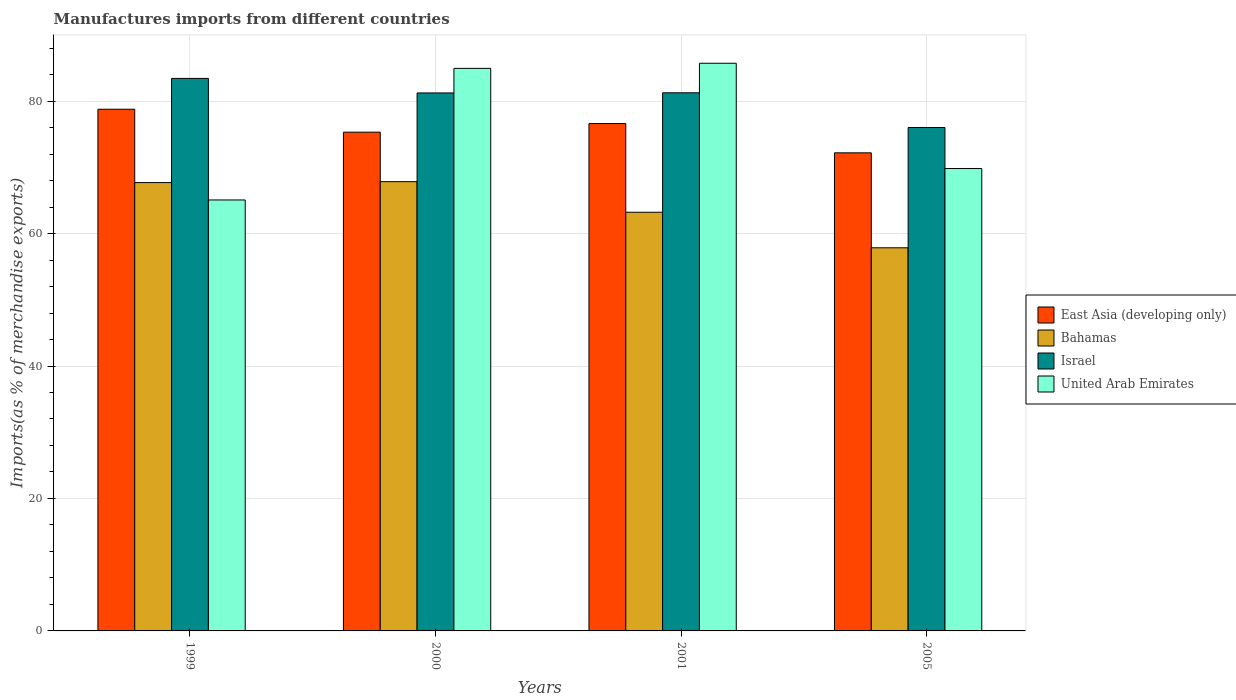How many different coloured bars are there?
Provide a succinct answer. 4. Are the number of bars per tick equal to the number of legend labels?
Give a very brief answer. Yes. How many bars are there on the 1st tick from the left?
Keep it short and to the point. 4. What is the percentage of imports to different countries in East Asia (developing only) in 2005?
Ensure brevity in your answer.  72.19. Across all years, what is the maximum percentage of imports to different countries in Bahamas?
Your answer should be compact. 67.84. Across all years, what is the minimum percentage of imports to different countries in Bahamas?
Your answer should be compact. 57.85. In which year was the percentage of imports to different countries in Israel minimum?
Offer a terse response. 2005. What is the total percentage of imports to different countries in East Asia (developing only) in the graph?
Ensure brevity in your answer.  302.89. What is the difference between the percentage of imports to different countries in East Asia (developing only) in 1999 and that in 2005?
Give a very brief answer. 6.58. What is the difference between the percentage of imports to different countries in East Asia (developing only) in 2000 and the percentage of imports to different countries in United Arab Emirates in 2001?
Provide a short and direct response. -10.4. What is the average percentage of imports to different countries in Israel per year?
Your answer should be very brief. 80.48. In the year 1999, what is the difference between the percentage of imports to different countries in Bahamas and percentage of imports to different countries in Israel?
Provide a succinct answer. -15.73. In how many years, is the percentage of imports to different countries in Israel greater than 44 %?
Provide a short and direct response. 4. What is the ratio of the percentage of imports to different countries in United Arab Emirates in 1999 to that in 2000?
Keep it short and to the point. 0.77. Is the difference between the percentage of imports to different countries in Bahamas in 2001 and 2005 greater than the difference between the percentage of imports to different countries in Israel in 2001 and 2005?
Keep it short and to the point. Yes. What is the difference between the highest and the second highest percentage of imports to different countries in East Asia (developing only)?
Provide a short and direct response. 2.16. What is the difference between the highest and the lowest percentage of imports to different countries in East Asia (developing only)?
Give a very brief answer. 6.58. In how many years, is the percentage of imports to different countries in Israel greater than the average percentage of imports to different countries in Israel taken over all years?
Ensure brevity in your answer.  3. Is the sum of the percentage of imports to different countries in United Arab Emirates in 2000 and 2005 greater than the maximum percentage of imports to different countries in Israel across all years?
Give a very brief answer. Yes. What does the 2nd bar from the left in 1999 represents?
Give a very brief answer. Bahamas. Is it the case that in every year, the sum of the percentage of imports to different countries in East Asia (developing only) and percentage of imports to different countries in Israel is greater than the percentage of imports to different countries in United Arab Emirates?
Make the answer very short. Yes. Are all the bars in the graph horizontal?
Offer a very short reply. No. How many years are there in the graph?
Your answer should be compact. 4. What is the difference between two consecutive major ticks on the Y-axis?
Your answer should be compact. 20. Does the graph contain any zero values?
Ensure brevity in your answer.  No. Does the graph contain grids?
Your answer should be compact. Yes. Where does the legend appear in the graph?
Provide a succinct answer. Center right. How many legend labels are there?
Give a very brief answer. 4. What is the title of the graph?
Provide a short and direct response. Manufactures imports from different countries. What is the label or title of the Y-axis?
Your answer should be very brief. Imports(as % of merchandise exports). What is the Imports(as % of merchandise exports) in East Asia (developing only) in 1999?
Provide a succinct answer. 78.77. What is the Imports(as % of merchandise exports) of Bahamas in 1999?
Provide a succinct answer. 67.7. What is the Imports(as % of merchandise exports) in Israel in 1999?
Give a very brief answer. 83.43. What is the Imports(as % of merchandise exports) of United Arab Emirates in 1999?
Your answer should be very brief. 65.07. What is the Imports(as % of merchandise exports) of East Asia (developing only) in 2000?
Your response must be concise. 75.31. What is the Imports(as % of merchandise exports) of Bahamas in 2000?
Provide a short and direct response. 67.84. What is the Imports(as % of merchandise exports) in Israel in 2000?
Ensure brevity in your answer.  81.23. What is the Imports(as % of merchandise exports) in United Arab Emirates in 2000?
Make the answer very short. 84.94. What is the Imports(as % of merchandise exports) in East Asia (developing only) in 2001?
Offer a very short reply. 76.61. What is the Imports(as % of merchandise exports) in Bahamas in 2001?
Offer a very short reply. 63.22. What is the Imports(as % of merchandise exports) in Israel in 2001?
Provide a succinct answer. 81.25. What is the Imports(as % of merchandise exports) of United Arab Emirates in 2001?
Offer a terse response. 85.72. What is the Imports(as % of merchandise exports) of East Asia (developing only) in 2005?
Offer a very short reply. 72.19. What is the Imports(as % of merchandise exports) of Bahamas in 2005?
Offer a terse response. 57.85. What is the Imports(as % of merchandise exports) in Israel in 2005?
Your answer should be very brief. 76.02. What is the Imports(as % of merchandise exports) in United Arab Emirates in 2005?
Ensure brevity in your answer.  69.82. Across all years, what is the maximum Imports(as % of merchandise exports) in East Asia (developing only)?
Provide a short and direct response. 78.77. Across all years, what is the maximum Imports(as % of merchandise exports) of Bahamas?
Provide a succinct answer. 67.84. Across all years, what is the maximum Imports(as % of merchandise exports) of Israel?
Your answer should be compact. 83.43. Across all years, what is the maximum Imports(as % of merchandise exports) in United Arab Emirates?
Your answer should be compact. 85.72. Across all years, what is the minimum Imports(as % of merchandise exports) of East Asia (developing only)?
Give a very brief answer. 72.19. Across all years, what is the minimum Imports(as % of merchandise exports) of Bahamas?
Offer a very short reply. 57.85. Across all years, what is the minimum Imports(as % of merchandise exports) of Israel?
Keep it short and to the point. 76.02. Across all years, what is the minimum Imports(as % of merchandise exports) of United Arab Emirates?
Your answer should be compact. 65.07. What is the total Imports(as % of merchandise exports) of East Asia (developing only) in the graph?
Ensure brevity in your answer.  302.89. What is the total Imports(as % of merchandise exports) in Bahamas in the graph?
Make the answer very short. 256.6. What is the total Imports(as % of merchandise exports) of Israel in the graph?
Make the answer very short. 321.93. What is the total Imports(as % of merchandise exports) in United Arab Emirates in the graph?
Make the answer very short. 305.55. What is the difference between the Imports(as % of merchandise exports) in East Asia (developing only) in 1999 and that in 2000?
Provide a short and direct response. 3.46. What is the difference between the Imports(as % of merchandise exports) of Bahamas in 1999 and that in 2000?
Give a very brief answer. -0.14. What is the difference between the Imports(as % of merchandise exports) of Israel in 1999 and that in 2000?
Make the answer very short. 2.2. What is the difference between the Imports(as % of merchandise exports) in United Arab Emirates in 1999 and that in 2000?
Give a very brief answer. -19.87. What is the difference between the Imports(as % of merchandise exports) of East Asia (developing only) in 1999 and that in 2001?
Give a very brief answer. 2.16. What is the difference between the Imports(as % of merchandise exports) of Bahamas in 1999 and that in 2001?
Offer a terse response. 4.48. What is the difference between the Imports(as % of merchandise exports) of Israel in 1999 and that in 2001?
Offer a terse response. 2.18. What is the difference between the Imports(as % of merchandise exports) in United Arab Emirates in 1999 and that in 2001?
Provide a succinct answer. -20.64. What is the difference between the Imports(as % of merchandise exports) of East Asia (developing only) in 1999 and that in 2005?
Provide a succinct answer. 6.58. What is the difference between the Imports(as % of merchandise exports) in Bahamas in 1999 and that in 2005?
Give a very brief answer. 9.85. What is the difference between the Imports(as % of merchandise exports) in Israel in 1999 and that in 2005?
Provide a short and direct response. 7.41. What is the difference between the Imports(as % of merchandise exports) of United Arab Emirates in 1999 and that in 2005?
Ensure brevity in your answer.  -4.75. What is the difference between the Imports(as % of merchandise exports) of East Asia (developing only) in 2000 and that in 2001?
Offer a terse response. -1.3. What is the difference between the Imports(as % of merchandise exports) in Bahamas in 2000 and that in 2001?
Your response must be concise. 4.62. What is the difference between the Imports(as % of merchandise exports) of Israel in 2000 and that in 2001?
Provide a succinct answer. -0.02. What is the difference between the Imports(as % of merchandise exports) of United Arab Emirates in 2000 and that in 2001?
Ensure brevity in your answer.  -0.77. What is the difference between the Imports(as % of merchandise exports) in East Asia (developing only) in 2000 and that in 2005?
Give a very brief answer. 3.12. What is the difference between the Imports(as % of merchandise exports) in Bahamas in 2000 and that in 2005?
Make the answer very short. 9.99. What is the difference between the Imports(as % of merchandise exports) in Israel in 2000 and that in 2005?
Provide a short and direct response. 5.22. What is the difference between the Imports(as % of merchandise exports) of United Arab Emirates in 2000 and that in 2005?
Offer a very short reply. 15.13. What is the difference between the Imports(as % of merchandise exports) in East Asia (developing only) in 2001 and that in 2005?
Your answer should be compact. 4.42. What is the difference between the Imports(as % of merchandise exports) in Bahamas in 2001 and that in 2005?
Make the answer very short. 5.37. What is the difference between the Imports(as % of merchandise exports) in Israel in 2001 and that in 2005?
Your answer should be very brief. 5.24. What is the difference between the Imports(as % of merchandise exports) of United Arab Emirates in 2001 and that in 2005?
Offer a terse response. 15.9. What is the difference between the Imports(as % of merchandise exports) in East Asia (developing only) in 1999 and the Imports(as % of merchandise exports) in Bahamas in 2000?
Provide a short and direct response. 10.94. What is the difference between the Imports(as % of merchandise exports) of East Asia (developing only) in 1999 and the Imports(as % of merchandise exports) of Israel in 2000?
Your answer should be very brief. -2.46. What is the difference between the Imports(as % of merchandise exports) of East Asia (developing only) in 1999 and the Imports(as % of merchandise exports) of United Arab Emirates in 2000?
Provide a short and direct response. -6.17. What is the difference between the Imports(as % of merchandise exports) of Bahamas in 1999 and the Imports(as % of merchandise exports) of Israel in 2000?
Keep it short and to the point. -13.54. What is the difference between the Imports(as % of merchandise exports) of Bahamas in 1999 and the Imports(as % of merchandise exports) of United Arab Emirates in 2000?
Offer a terse response. -17.25. What is the difference between the Imports(as % of merchandise exports) of Israel in 1999 and the Imports(as % of merchandise exports) of United Arab Emirates in 2000?
Ensure brevity in your answer.  -1.51. What is the difference between the Imports(as % of merchandise exports) in East Asia (developing only) in 1999 and the Imports(as % of merchandise exports) in Bahamas in 2001?
Make the answer very short. 15.55. What is the difference between the Imports(as % of merchandise exports) in East Asia (developing only) in 1999 and the Imports(as % of merchandise exports) in Israel in 2001?
Make the answer very short. -2.48. What is the difference between the Imports(as % of merchandise exports) in East Asia (developing only) in 1999 and the Imports(as % of merchandise exports) in United Arab Emirates in 2001?
Provide a short and direct response. -6.94. What is the difference between the Imports(as % of merchandise exports) in Bahamas in 1999 and the Imports(as % of merchandise exports) in Israel in 2001?
Make the answer very short. -13.56. What is the difference between the Imports(as % of merchandise exports) in Bahamas in 1999 and the Imports(as % of merchandise exports) in United Arab Emirates in 2001?
Offer a very short reply. -18.02. What is the difference between the Imports(as % of merchandise exports) of Israel in 1999 and the Imports(as % of merchandise exports) of United Arab Emirates in 2001?
Keep it short and to the point. -2.29. What is the difference between the Imports(as % of merchandise exports) of East Asia (developing only) in 1999 and the Imports(as % of merchandise exports) of Bahamas in 2005?
Your answer should be compact. 20.92. What is the difference between the Imports(as % of merchandise exports) in East Asia (developing only) in 1999 and the Imports(as % of merchandise exports) in Israel in 2005?
Provide a succinct answer. 2.76. What is the difference between the Imports(as % of merchandise exports) in East Asia (developing only) in 1999 and the Imports(as % of merchandise exports) in United Arab Emirates in 2005?
Provide a succinct answer. 8.95. What is the difference between the Imports(as % of merchandise exports) of Bahamas in 1999 and the Imports(as % of merchandise exports) of Israel in 2005?
Your response must be concise. -8.32. What is the difference between the Imports(as % of merchandise exports) in Bahamas in 1999 and the Imports(as % of merchandise exports) in United Arab Emirates in 2005?
Provide a succinct answer. -2.12. What is the difference between the Imports(as % of merchandise exports) of Israel in 1999 and the Imports(as % of merchandise exports) of United Arab Emirates in 2005?
Ensure brevity in your answer.  13.61. What is the difference between the Imports(as % of merchandise exports) of East Asia (developing only) in 2000 and the Imports(as % of merchandise exports) of Bahamas in 2001?
Your answer should be compact. 12.09. What is the difference between the Imports(as % of merchandise exports) of East Asia (developing only) in 2000 and the Imports(as % of merchandise exports) of Israel in 2001?
Your answer should be very brief. -5.94. What is the difference between the Imports(as % of merchandise exports) of East Asia (developing only) in 2000 and the Imports(as % of merchandise exports) of United Arab Emirates in 2001?
Your answer should be compact. -10.4. What is the difference between the Imports(as % of merchandise exports) of Bahamas in 2000 and the Imports(as % of merchandise exports) of Israel in 2001?
Offer a very short reply. -13.42. What is the difference between the Imports(as % of merchandise exports) in Bahamas in 2000 and the Imports(as % of merchandise exports) in United Arab Emirates in 2001?
Provide a short and direct response. -17.88. What is the difference between the Imports(as % of merchandise exports) in Israel in 2000 and the Imports(as % of merchandise exports) in United Arab Emirates in 2001?
Ensure brevity in your answer.  -4.48. What is the difference between the Imports(as % of merchandise exports) in East Asia (developing only) in 2000 and the Imports(as % of merchandise exports) in Bahamas in 2005?
Your answer should be compact. 17.46. What is the difference between the Imports(as % of merchandise exports) of East Asia (developing only) in 2000 and the Imports(as % of merchandise exports) of Israel in 2005?
Make the answer very short. -0.7. What is the difference between the Imports(as % of merchandise exports) in East Asia (developing only) in 2000 and the Imports(as % of merchandise exports) in United Arab Emirates in 2005?
Make the answer very short. 5.49. What is the difference between the Imports(as % of merchandise exports) of Bahamas in 2000 and the Imports(as % of merchandise exports) of Israel in 2005?
Make the answer very short. -8.18. What is the difference between the Imports(as % of merchandise exports) of Bahamas in 2000 and the Imports(as % of merchandise exports) of United Arab Emirates in 2005?
Offer a very short reply. -1.98. What is the difference between the Imports(as % of merchandise exports) in Israel in 2000 and the Imports(as % of merchandise exports) in United Arab Emirates in 2005?
Offer a very short reply. 11.41. What is the difference between the Imports(as % of merchandise exports) of East Asia (developing only) in 2001 and the Imports(as % of merchandise exports) of Bahamas in 2005?
Your answer should be compact. 18.76. What is the difference between the Imports(as % of merchandise exports) of East Asia (developing only) in 2001 and the Imports(as % of merchandise exports) of Israel in 2005?
Your answer should be very brief. 0.6. What is the difference between the Imports(as % of merchandise exports) of East Asia (developing only) in 2001 and the Imports(as % of merchandise exports) of United Arab Emirates in 2005?
Your response must be concise. 6.79. What is the difference between the Imports(as % of merchandise exports) of Bahamas in 2001 and the Imports(as % of merchandise exports) of Israel in 2005?
Offer a very short reply. -12.8. What is the difference between the Imports(as % of merchandise exports) in Bahamas in 2001 and the Imports(as % of merchandise exports) in United Arab Emirates in 2005?
Provide a short and direct response. -6.6. What is the difference between the Imports(as % of merchandise exports) of Israel in 2001 and the Imports(as % of merchandise exports) of United Arab Emirates in 2005?
Offer a terse response. 11.43. What is the average Imports(as % of merchandise exports) in East Asia (developing only) per year?
Give a very brief answer. 75.72. What is the average Imports(as % of merchandise exports) of Bahamas per year?
Make the answer very short. 64.15. What is the average Imports(as % of merchandise exports) of Israel per year?
Ensure brevity in your answer.  80.48. What is the average Imports(as % of merchandise exports) of United Arab Emirates per year?
Your answer should be compact. 76.39. In the year 1999, what is the difference between the Imports(as % of merchandise exports) of East Asia (developing only) and Imports(as % of merchandise exports) of Bahamas?
Provide a short and direct response. 11.08. In the year 1999, what is the difference between the Imports(as % of merchandise exports) in East Asia (developing only) and Imports(as % of merchandise exports) in Israel?
Provide a short and direct response. -4.66. In the year 1999, what is the difference between the Imports(as % of merchandise exports) of East Asia (developing only) and Imports(as % of merchandise exports) of United Arab Emirates?
Offer a very short reply. 13.7. In the year 1999, what is the difference between the Imports(as % of merchandise exports) in Bahamas and Imports(as % of merchandise exports) in Israel?
Offer a terse response. -15.73. In the year 1999, what is the difference between the Imports(as % of merchandise exports) of Bahamas and Imports(as % of merchandise exports) of United Arab Emirates?
Your response must be concise. 2.62. In the year 1999, what is the difference between the Imports(as % of merchandise exports) of Israel and Imports(as % of merchandise exports) of United Arab Emirates?
Offer a terse response. 18.36. In the year 2000, what is the difference between the Imports(as % of merchandise exports) of East Asia (developing only) and Imports(as % of merchandise exports) of Bahamas?
Offer a very short reply. 7.47. In the year 2000, what is the difference between the Imports(as % of merchandise exports) in East Asia (developing only) and Imports(as % of merchandise exports) in Israel?
Provide a succinct answer. -5.92. In the year 2000, what is the difference between the Imports(as % of merchandise exports) in East Asia (developing only) and Imports(as % of merchandise exports) in United Arab Emirates?
Provide a short and direct response. -9.63. In the year 2000, what is the difference between the Imports(as % of merchandise exports) of Bahamas and Imports(as % of merchandise exports) of Israel?
Ensure brevity in your answer.  -13.4. In the year 2000, what is the difference between the Imports(as % of merchandise exports) in Bahamas and Imports(as % of merchandise exports) in United Arab Emirates?
Offer a very short reply. -17.11. In the year 2000, what is the difference between the Imports(as % of merchandise exports) of Israel and Imports(as % of merchandise exports) of United Arab Emirates?
Make the answer very short. -3.71. In the year 2001, what is the difference between the Imports(as % of merchandise exports) in East Asia (developing only) and Imports(as % of merchandise exports) in Bahamas?
Make the answer very short. 13.39. In the year 2001, what is the difference between the Imports(as % of merchandise exports) in East Asia (developing only) and Imports(as % of merchandise exports) in Israel?
Provide a succinct answer. -4.64. In the year 2001, what is the difference between the Imports(as % of merchandise exports) in East Asia (developing only) and Imports(as % of merchandise exports) in United Arab Emirates?
Your response must be concise. -9.1. In the year 2001, what is the difference between the Imports(as % of merchandise exports) of Bahamas and Imports(as % of merchandise exports) of Israel?
Make the answer very short. -18.04. In the year 2001, what is the difference between the Imports(as % of merchandise exports) in Bahamas and Imports(as % of merchandise exports) in United Arab Emirates?
Your answer should be very brief. -22.5. In the year 2001, what is the difference between the Imports(as % of merchandise exports) of Israel and Imports(as % of merchandise exports) of United Arab Emirates?
Your answer should be very brief. -4.46. In the year 2005, what is the difference between the Imports(as % of merchandise exports) in East Asia (developing only) and Imports(as % of merchandise exports) in Bahamas?
Offer a very short reply. 14.34. In the year 2005, what is the difference between the Imports(as % of merchandise exports) of East Asia (developing only) and Imports(as % of merchandise exports) of Israel?
Your response must be concise. -3.83. In the year 2005, what is the difference between the Imports(as % of merchandise exports) in East Asia (developing only) and Imports(as % of merchandise exports) in United Arab Emirates?
Offer a terse response. 2.37. In the year 2005, what is the difference between the Imports(as % of merchandise exports) in Bahamas and Imports(as % of merchandise exports) in Israel?
Ensure brevity in your answer.  -18.16. In the year 2005, what is the difference between the Imports(as % of merchandise exports) of Bahamas and Imports(as % of merchandise exports) of United Arab Emirates?
Offer a terse response. -11.97. In the year 2005, what is the difference between the Imports(as % of merchandise exports) in Israel and Imports(as % of merchandise exports) in United Arab Emirates?
Keep it short and to the point. 6.2. What is the ratio of the Imports(as % of merchandise exports) of East Asia (developing only) in 1999 to that in 2000?
Make the answer very short. 1.05. What is the ratio of the Imports(as % of merchandise exports) in United Arab Emirates in 1999 to that in 2000?
Provide a succinct answer. 0.77. What is the ratio of the Imports(as % of merchandise exports) of East Asia (developing only) in 1999 to that in 2001?
Your response must be concise. 1.03. What is the ratio of the Imports(as % of merchandise exports) of Bahamas in 1999 to that in 2001?
Make the answer very short. 1.07. What is the ratio of the Imports(as % of merchandise exports) in Israel in 1999 to that in 2001?
Make the answer very short. 1.03. What is the ratio of the Imports(as % of merchandise exports) of United Arab Emirates in 1999 to that in 2001?
Ensure brevity in your answer.  0.76. What is the ratio of the Imports(as % of merchandise exports) in East Asia (developing only) in 1999 to that in 2005?
Offer a very short reply. 1.09. What is the ratio of the Imports(as % of merchandise exports) of Bahamas in 1999 to that in 2005?
Give a very brief answer. 1.17. What is the ratio of the Imports(as % of merchandise exports) in Israel in 1999 to that in 2005?
Your answer should be very brief. 1.1. What is the ratio of the Imports(as % of merchandise exports) in United Arab Emirates in 1999 to that in 2005?
Ensure brevity in your answer.  0.93. What is the ratio of the Imports(as % of merchandise exports) of Bahamas in 2000 to that in 2001?
Provide a succinct answer. 1.07. What is the ratio of the Imports(as % of merchandise exports) of Israel in 2000 to that in 2001?
Your answer should be compact. 1. What is the ratio of the Imports(as % of merchandise exports) of East Asia (developing only) in 2000 to that in 2005?
Provide a succinct answer. 1.04. What is the ratio of the Imports(as % of merchandise exports) of Bahamas in 2000 to that in 2005?
Keep it short and to the point. 1.17. What is the ratio of the Imports(as % of merchandise exports) in Israel in 2000 to that in 2005?
Give a very brief answer. 1.07. What is the ratio of the Imports(as % of merchandise exports) of United Arab Emirates in 2000 to that in 2005?
Provide a short and direct response. 1.22. What is the ratio of the Imports(as % of merchandise exports) of East Asia (developing only) in 2001 to that in 2005?
Your answer should be very brief. 1.06. What is the ratio of the Imports(as % of merchandise exports) of Bahamas in 2001 to that in 2005?
Provide a short and direct response. 1.09. What is the ratio of the Imports(as % of merchandise exports) in Israel in 2001 to that in 2005?
Provide a succinct answer. 1.07. What is the ratio of the Imports(as % of merchandise exports) in United Arab Emirates in 2001 to that in 2005?
Provide a short and direct response. 1.23. What is the difference between the highest and the second highest Imports(as % of merchandise exports) of East Asia (developing only)?
Your answer should be compact. 2.16. What is the difference between the highest and the second highest Imports(as % of merchandise exports) of Bahamas?
Ensure brevity in your answer.  0.14. What is the difference between the highest and the second highest Imports(as % of merchandise exports) in Israel?
Offer a terse response. 2.18. What is the difference between the highest and the second highest Imports(as % of merchandise exports) in United Arab Emirates?
Your response must be concise. 0.77. What is the difference between the highest and the lowest Imports(as % of merchandise exports) in East Asia (developing only)?
Provide a succinct answer. 6.58. What is the difference between the highest and the lowest Imports(as % of merchandise exports) of Bahamas?
Your response must be concise. 9.99. What is the difference between the highest and the lowest Imports(as % of merchandise exports) in Israel?
Provide a short and direct response. 7.41. What is the difference between the highest and the lowest Imports(as % of merchandise exports) in United Arab Emirates?
Ensure brevity in your answer.  20.64. 